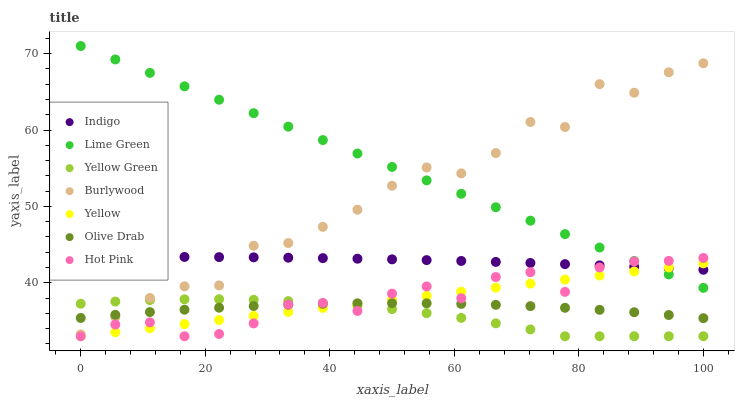Does Yellow Green have the minimum area under the curve?
Answer yes or no. Yes. Does Lime Green have the maximum area under the curve?
Answer yes or no. Yes. Does Burlywood have the minimum area under the curve?
Answer yes or no. No. Does Burlywood have the maximum area under the curve?
Answer yes or no. No. Is Lime Green the smoothest?
Answer yes or no. Yes. Is Burlywood the roughest?
Answer yes or no. Yes. Is Yellow Green the smoothest?
Answer yes or no. No. Is Yellow Green the roughest?
Answer yes or no. No. Does Yellow Green have the lowest value?
Answer yes or no. Yes. Does Burlywood have the lowest value?
Answer yes or no. No. Does Lime Green have the highest value?
Answer yes or no. Yes. Does Yellow Green have the highest value?
Answer yes or no. No. Is Olive Drab less than Lime Green?
Answer yes or no. Yes. Is Burlywood greater than Hot Pink?
Answer yes or no. Yes. Does Yellow intersect Indigo?
Answer yes or no. Yes. Is Yellow less than Indigo?
Answer yes or no. No. Is Yellow greater than Indigo?
Answer yes or no. No. Does Olive Drab intersect Lime Green?
Answer yes or no. No. 